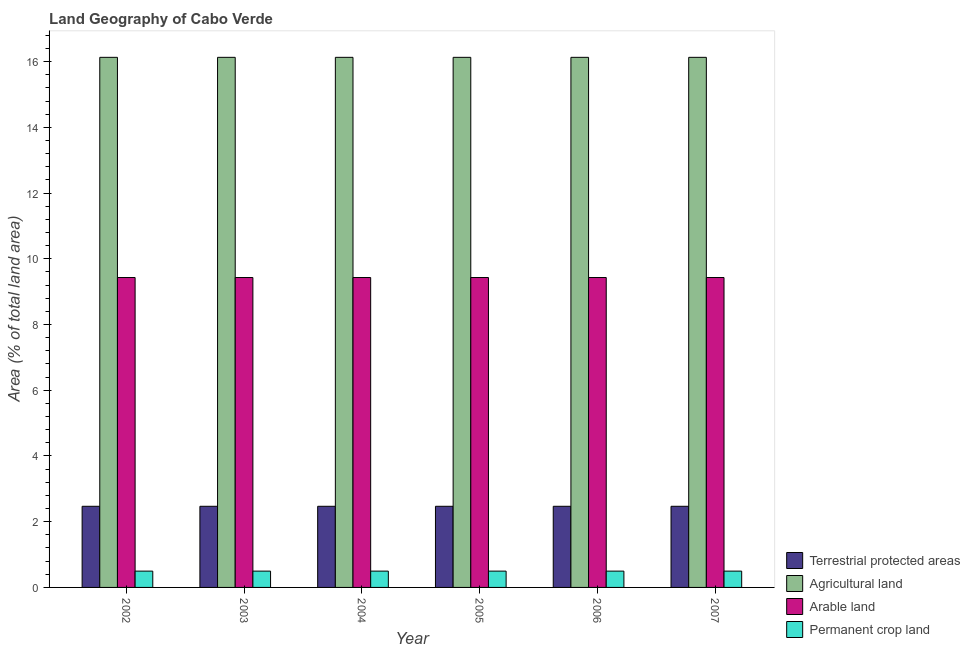How many different coloured bars are there?
Offer a terse response. 4. How many bars are there on the 6th tick from the left?
Offer a terse response. 4. What is the label of the 6th group of bars from the left?
Provide a succinct answer. 2007. In how many cases, is the number of bars for a given year not equal to the number of legend labels?
Offer a very short reply. 0. What is the percentage of area under arable land in 2004?
Provide a succinct answer. 9.43. Across all years, what is the maximum percentage of area under permanent crop land?
Your response must be concise. 0.5. Across all years, what is the minimum percentage of area under arable land?
Give a very brief answer. 9.43. In which year was the percentage of land under terrestrial protection minimum?
Provide a short and direct response. 2002. What is the total percentage of land under terrestrial protection in the graph?
Make the answer very short. 14.81. What is the average percentage of land under terrestrial protection per year?
Ensure brevity in your answer.  2.47. In the year 2004, what is the difference between the percentage of area under permanent crop land and percentage of land under terrestrial protection?
Your response must be concise. 0. In how many years, is the percentage of land under terrestrial protection greater than 8.8 %?
Offer a terse response. 0. What is the ratio of the percentage of area under permanent crop land in 2004 to that in 2005?
Your answer should be compact. 1. Is the percentage of area under agricultural land in 2004 less than that in 2007?
Provide a short and direct response. No. Is the difference between the percentage of area under arable land in 2002 and 2005 greater than the difference between the percentage of land under terrestrial protection in 2002 and 2005?
Provide a succinct answer. No. What is the difference between the highest and the lowest percentage of area under agricultural land?
Your answer should be compact. 0. Is it the case that in every year, the sum of the percentage of area under permanent crop land and percentage of area under arable land is greater than the sum of percentage of land under terrestrial protection and percentage of area under agricultural land?
Give a very brief answer. No. What does the 4th bar from the left in 2002 represents?
Provide a succinct answer. Permanent crop land. What does the 1st bar from the right in 2006 represents?
Your answer should be compact. Permanent crop land. How many bars are there?
Ensure brevity in your answer.  24. Are the values on the major ticks of Y-axis written in scientific E-notation?
Ensure brevity in your answer.  No. Does the graph contain any zero values?
Make the answer very short. No. Does the graph contain grids?
Your response must be concise. No. How many legend labels are there?
Offer a very short reply. 4. How are the legend labels stacked?
Ensure brevity in your answer.  Vertical. What is the title of the graph?
Your answer should be compact. Land Geography of Cabo Verde. Does "Regional development banks" appear as one of the legend labels in the graph?
Keep it short and to the point. No. What is the label or title of the Y-axis?
Keep it short and to the point. Area (% of total land area). What is the Area (% of total land area) of Terrestrial protected areas in 2002?
Offer a terse response. 2.47. What is the Area (% of total land area) in Agricultural land in 2002?
Offer a very short reply. 16.13. What is the Area (% of total land area) in Arable land in 2002?
Make the answer very short. 9.43. What is the Area (% of total land area) in Permanent crop land in 2002?
Offer a very short reply. 0.5. What is the Area (% of total land area) of Terrestrial protected areas in 2003?
Offer a very short reply. 2.47. What is the Area (% of total land area) of Agricultural land in 2003?
Provide a short and direct response. 16.13. What is the Area (% of total land area) in Arable land in 2003?
Provide a succinct answer. 9.43. What is the Area (% of total land area) in Permanent crop land in 2003?
Ensure brevity in your answer.  0.5. What is the Area (% of total land area) in Terrestrial protected areas in 2004?
Your answer should be very brief. 2.47. What is the Area (% of total land area) of Agricultural land in 2004?
Your response must be concise. 16.13. What is the Area (% of total land area) in Arable land in 2004?
Offer a very short reply. 9.43. What is the Area (% of total land area) in Permanent crop land in 2004?
Keep it short and to the point. 0.5. What is the Area (% of total land area) in Terrestrial protected areas in 2005?
Ensure brevity in your answer.  2.47. What is the Area (% of total land area) in Agricultural land in 2005?
Provide a succinct answer. 16.13. What is the Area (% of total land area) of Arable land in 2005?
Offer a terse response. 9.43. What is the Area (% of total land area) in Permanent crop land in 2005?
Offer a terse response. 0.5. What is the Area (% of total land area) of Terrestrial protected areas in 2006?
Provide a short and direct response. 2.47. What is the Area (% of total land area) in Agricultural land in 2006?
Ensure brevity in your answer.  16.13. What is the Area (% of total land area) in Arable land in 2006?
Keep it short and to the point. 9.43. What is the Area (% of total land area) of Permanent crop land in 2006?
Make the answer very short. 0.5. What is the Area (% of total land area) of Terrestrial protected areas in 2007?
Give a very brief answer. 2.47. What is the Area (% of total land area) of Agricultural land in 2007?
Your answer should be compact. 16.13. What is the Area (% of total land area) in Arable land in 2007?
Provide a short and direct response. 9.43. What is the Area (% of total land area) in Permanent crop land in 2007?
Your answer should be compact. 0.5. Across all years, what is the maximum Area (% of total land area) in Terrestrial protected areas?
Offer a very short reply. 2.47. Across all years, what is the maximum Area (% of total land area) in Agricultural land?
Provide a short and direct response. 16.13. Across all years, what is the maximum Area (% of total land area) in Arable land?
Make the answer very short. 9.43. Across all years, what is the maximum Area (% of total land area) in Permanent crop land?
Offer a terse response. 0.5. Across all years, what is the minimum Area (% of total land area) in Terrestrial protected areas?
Offer a terse response. 2.47. Across all years, what is the minimum Area (% of total land area) in Agricultural land?
Give a very brief answer. 16.13. Across all years, what is the minimum Area (% of total land area) in Arable land?
Ensure brevity in your answer.  9.43. Across all years, what is the minimum Area (% of total land area) in Permanent crop land?
Ensure brevity in your answer.  0.5. What is the total Area (% of total land area) in Terrestrial protected areas in the graph?
Offer a terse response. 14.81. What is the total Area (% of total land area) in Agricultural land in the graph?
Keep it short and to the point. 96.77. What is the total Area (% of total land area) of Arable land in the graph?
Give a very brief answer. 56.58. What is the total Area (% of total land area) in Permanent crop land in the graph?
Your answer should be compact. 2.98. What is the difference between the Area (% of total land area) in Arable land in 2002 and that in 2003?
Make the answer very short. 0. What is the difference between the Area (% of total land area) in Permanent crop land in 2002 and that in 2003?
Provide a succinct answer. 0. What is the difference between the Area (% of total land area) in Agricultural land in 2002 and that in 2004?
Your response must be concise. 0. What is the difference between the Area (% of total land area) of Arable land in 2002 and that in 2004?
Offer a terse response. 0. What is the difference between the Area (% of total land area) in Agricultural land in 2002 and that in 2005?
Provide a short and direct response. 0. What is the difference between the Area (% of total land area) in Permanent crop land in 2002 and that in 2005?
Your answer should be compact. 0. What is the difference between the Area (% of total land area) of Agricultural land in 2002 and that in 2007?
Offer a very short reply. 0. What is the difference between the Area (% of total land area) in Terrestrial protected areas in 2003 and that in 2004?
Provide a short and direct response. 0. What is the difference between the Area (% of total land area) of Permanent crop land in 2003 and that in 2004?
Give a very brief answer. 0. What is the difference between the Area (% of total land area) in Terrestrial protected areas in 2003 and that in 2005?
Keep it short and to the point. 0. What is the difference between the Area (% of total land area) of Arable land in 2003 and that in 2005?
Ensure brevity in your answer.  0. What is the difference between the Area (% of total land area) of Arable land in 2003 and that in 2006?
Ensure brevity in your answer.  0. What is the difference between the Area (% of total land area) of Permanent crop land in 2003 and that in 2006?
Your answer should be compact. 0. What is the difference between the Area (% of total land area) in Terrestrial protected areas in 2003 and that in 2007?
Your answer should be very brief. 0. What is the difference between the Area (% of total land area) in Agricultural land in 2003 and that in 2007?
Keep it short and to the point. 0. What is the difference between the Area (% of total land area) of Terrestrial protected areas in 2004 and that in 2005?
Give a very brief answer. 0. What is the difference between the Area (% of total land area) of Arable land in 2004 and that in 2005?
Your response must be concise. 0. What is the difference between the Area (% of total land area) in Permanent crop land in 2004 and that in 2005?
Make the answer very short. 0. What is the difference between the Area (% of total land area) in Arable land in 2004 and that in 2006?
Make the answer very short. 0. What is the difference between the Area (% of total land area) of Permanent crop land in 2004 and that in 2006?
Provide a short and direct response. 0. What is the difference between the Area (% of total land area) of Terrestrial protected areas in 2004 and that in 2007?
Your response must be concise. 0. What is the difference between the Area (% of total land area) of Agricultural land in 2004 and that in 2007?
Offer a terse response. 0. What is the difference between the Area (% of total land area) of Arable land in 2005 and that in 2006?
Offer a terse response. 0. What is the difference between the Area (% of total land area) of Permanent crop land in 2005 and that in 2007?
Your answer should be compact. 0. What is the difference between the Area (% of total land area) of Terrestrial protected areas in 2006 and that in 2007?
Give a very brief answer. 0. What is the difference between the Area (% of total land area) in Terrestrial protected areas in 2002 and the Area (% of total land area) in Agricultural land in 2003?
Your response must be concise. -13.66. What is the difference between the Area (% of total land area) in Terrestrial protected areas in 2002 and the Area (% of total land area) in Arable land in 2003?
Provide a short and direct response. -6.96. What is the difference between the Area (% of total land area) in Terrestrial protected areas in 2002 and the Area (% of total land area) in Permanent crop land in 2003?
Provide a succinct answer. 1.97. What is the difference between the Area (% of total land area) in Agricultural land in 2002 and the Area (% of total land area) in Arable land in 2003?
Give a very brief answer. 6.7. What is the difference between the Area (% of total land area) in Agricultural land in 2002 and the Area (% of total land area) in Permanent crop land in 2003?
Your answer should be compact. 15.63. What is the difference between the Area (% of total land area) in Arable land in 2002 and the Area (% of total land area) in Permanent crop land in 2003?
Provide a short and direct response. 8.93. What is the difference between the Area (% of total land area) of Terrestrial protected areas in 2002 and the Area (% of total land area) of Agricultural land in 2004?
Offer a terse response. -13.66. What is the difference between the Area (% of total land area) in Terrestrial protected areas in 2002 and the Area (% of total land area) in Arable land in 2004?
Ensure brevity in your answer.  -6.96. What is the difference between the Area (% of total land area) in Terrestrial protected areas in 2002 and the Area (% of total land area) in Permanent crop land in 2004?
Give a very brief answer. 1.97. What is the difference between the Area (% of total land area) of Agricultural land in 2002 and the Area (% of total land area) of Arable land in 2004?
Make the answer very short. 6.7. What is the difference between the Area (% of total land area) in Agricultural land in 2002 and the Area (% of total land area) in Permanent crop land in 2004?
Ensure brevity in your answer.  15.63. What is the difference between the Area (% of total land area) of Arable land in 2002 and the Area (% of total land area) of Permanent crop land in 2004?
Keep it short and to the point. 8.93. What is the difference between the Area (% of total land area) of Terrestrial protected areas in 2002 and the Area (% of total land area) of Agricultural land in 2005?
Your response must be concise. -13.66. What is the difference between the Area (% of total land area) of Terrestrial protected areas in 2002 and the Area (% of total land area) of Arable land in 2005?
Provide a succinct answer. -6.96. What is the difference between the Area (% of total land area) of Terrestrial protected areas in 2002 and the Area (% of total land area) of Permanent crop land in 2005?
Your response must be concise. 1.97. What is the difference between the Area (% of total land area) in Agricultural land in 2002 and the Area (% of total land area) in Arable land in 2005?
Your answer should be very brief. 6.7. What is the difference between the Area (% of total land area) of Agricultural land in 2002 and the Area (% of total land area) of Permanent crop land in 2005?
Ensure brevity in your answer.  15.63. What is the difference between the Area (% of total land area) in Arable land in 2002 and the Area (% of total land area) in Permanent crop land in 2005?
Provide a short and direct response. 8.93. What is the difference between the Area (% of total land area) of Terrestrial protected areas in 2002 and the Area (% of total land area) of Agricultural land in 2006?
Your answer should be very brief. -13.66. What is the difference between the Area (% of total land area) of Terrestrial protected areas in 2002 and the Area (% of total land area) of Arable land in 2006?
Give a very brief answer. -6.96. What is the difference between the Area (% of total land area) in Terrestrial protected areas in 2002 and the Area (% of total land area) in Permanent crop land in 2006?
Keep it short and to the point. 1.97. What is the difference between the Area (% of total land area) in Agricultural land in 2002 and the Area (% of total land area) in Arable land in 2006?
Provide a short and direct response. 6.7. What is the difference between the Area (% of total land area) of Agricultural land in 2002 and the Area (% of total land area) of Permanent crop land in 2006?
Ensure brevity in your answer.  15.63. What is the difference between the Area (% of total land area) of Arable land in 2002 and the Area (% of total land area) of Permanent crop land in 2006?
Provide a succinct answer. 8.93. What is the difference between the Area (% of total land area) in Terrestrial protected areas in 2002 and the Area (% of total land area) in Agricultural land in 2007?
Make the answer very short. -13.66. What is the difference between the Area (% of total land area) in Terrestrial protected areas in 2002 and the Area (% of total land area) in Arable land in 2007?
Give a very brief answer. -6.96. What is the difference between the Area (% of total land area) of Terrestrial protected areas in 2002 and the Area (% of total land area) of Permanent crop land in 2007?
Provide a succinct answer. 1.97. What is the difference between the Area (% of total land area) of Agricultural land in 2002 and the Area (% of total land area) of Arable land in 2007?
Make the answer very short. 6.7. What is the difference between the Area (% of total land area) of Agricultural land in 2002 and the Area (% of total land area) of Permanent crop land in 2007?
Provide a short and direct response. 15.63. What is the difference between the Area (% of total land area) of Arable land in 2002 and the Area (% of total land area) of Permanent crop land in 2007?
Offer a very short reply. 8.93. What is the difference between the Area (% of total land area) in Terrestrial protected areas in 2003 and the Area (% of total land area) in Agricultural land in 2004?
Your response must be concise. -13.66. What is the difference between the Area (% of total land area) of Terrestrial protected areas in 2003 and the Area (% of total land area) of Arable land in 2004?
Keep it short and to the point. -6.96. What is the difference between the Area (% of total land area) of Terrestrial protected areas in 2003 and the Area (% of total land area) of Permanent crop land in 2004?
Keep it short and to the point. 1.97. What is the difference between the Area (% of total land area) in Agricultural land in 2003 and the Area (% of total land area) in Arable land in 2004?
Ensure brevity in your answer.  6.7. What is the difference between the Area (% of total land area) of Agricultural land in 2003 and the Area (% of total land area) of Permanent crop land in 2004?
Your answer should be compact. 15.63. What is the difference between the Area (% of total land area) in Arable land in 2003 and the Area (% of total land area) in Permanent crop land in 2004?
Offer a very short reply. 8.93. What is the difference between the Area (% of total land area) of Terrestrial protected areas in 2003 and the Area (% of total land area) of Agricultural land in 2005?
Offer a terse response. -13.66. What is the difference between the Area (% of total land area) in Terrestrial protected areas in 2003 and the Area (% of total land area) in Arable land in 2005?
Give a very brief answer. -6.96. What is the difference between the Area (% of total land area) of Terrestrial protected areas in 2003 and the Area (% of total land area) of Permanent crop land in 2005?
Give a very brief answer. 1.97. What is the difference between the Area (% of total land area) of Agricultural land in 2003 and the Area (% of total land area) of Arable land in 2005?
Offer a terse response. 6.7. What is the difference between the Area (% of total land area) in Agricultural land in 2003 and the Area (% of total land area) in Permanent crop land in 2005?
Provide a succinct answer. 15.63. What is the difference between the Area (% of total land area) in Arable land in 2003 and the Area (% of total land area) in Permanent crop land in 2005?
Provide a succinct answer. 8.93. What is the difference between the Area (% of total land area) in Terrestrial protected areas in 2003 and the Area (% of total land area) in Agricultural land in 2006?
Your response must be concise. -13.66. What is the difference between the Area (% of total land area) of Terrestrial protected areas in 2003 and the Area (% of total land area) of Arable land in 2006?
Your response must be concise. -6.96. What is the difference between the Area (% of total land area) of Terrestrial protected areas in 2003 and the Area (% of total land area) of Permanent crop land in 2006?
Make the answer very short. 1.97. What is the difference between the Area (% of total land area) of Agricultural land in 2003 and the Area (% of total land area) of Arable land in 2006?
Offer a very short reply. 6.7. What is the difference between the Area (% of total land area) of Agricultural land in 2003 and the Area (% of total land area) of Permanent crop land in 2006?
Offer a very short reply. 15.63. What is the difference between the Area (% of total land area) of Arable land in 2003 and the Area (% of total land area) of Permanent crop land in 2006?
Offer a terse response. 8.93. What is the difference between the Area (% of total land area) of Terrestrial protected areas in 2003 and the Area (% of total land area) of Agricultural land in 2007?
Ensure brevity in your answer.  -13.66. What is the difference between the Area (% of total land area) of Terrestrial protected areas in 2003 and the Area (% of total land area) of Arable land in 2007?
Ensure brevity in your answer.  -6.96. What is the difference between the Area (% of total land area) of Terrestrial protected areas in 2003 and the Area (% of total land area) of Permanent crop land in 2007?
Offer a terse response. 1.97. What is the difference between the Area (% of total land area) in Agricultural land in 2003 and the Area (% of total land area) in Arable land in 2007?
Offer a very short reply. 6.7. What is the difference between the Area (% of total land area) of Agricultural land in 2003 and the Area (% of total land area) of Permanent crop land in 2007?
Ensure brevity in your answer.  15.63. What is the difference between the Area (% of total land area) of Arable land in 2003 and the Area (% of total land area) of Permanent crop land in 2007?
Offer a terse response. 8.93. What is the difference between the Area (% of total land area) of Terrestrial protected areas in 2004 and the Area (% of total land area) of Agricultural land in 2005?
Make the answer very short. -13.66. What is the difference between the Area (% of total land area) of Terrestrial protected areas in 2004 and the Area (% of total land area) of Arable land in 2005?
Offer a very short reply. -6.96. What is the difference between the Area (% of total land area) of Terrestrial protected areas in 2004 and the Area (% of total land area) of Permanent crop land in 2005?
Your response must be concise. 1.97. What is the difference between the Area (% of total land area) in Agricultural land in 2004 and the Area (% of total land area) in Arable land in 2005?
Your answer should be very brief. 6.7. What is the difference between the Area (% of total land area) of Agricultural land in 2004 and the Area (% of total land area) of Permanent crop land in 2005?
Offer a terse response. 15.63. What is the difference between the Area (% of total land area) in Arable land in 2004 and the Area (% of total land area) in Permanent crop land in 2005?
Keep it short and to the point. 8.93. What is the difference between the Area (% of total land area) of Terrestrial protected areas in 2004 and the Area (% of total land area) of Agricultural land in 2006?
Provide a succinct answer. -13.66. What is the difference between the Area (% of total land area) in Terrestrial protected areas in 2004 and the Area (% of total land area) in Arable land in 2006?
Offer a terse response. -6.96. What is the difference between the Area (% of total land area) of Terrestrial protected areas in 2004 and the Area (% of total land area) of Permanent crop land in 2006?
Make the answer very short. 1.97. What is the difference between the Area (% of total land area) of Agricultural land in 2004 and the Area (% of total land area) of Arable land in 2006?
Give a very brief answer. 6.7. What is the difference between the Area (% of total land area) in Agricultural land in 2004 and the Area (% of total land area) in Permanent crop land in 2006?
Provide a succinct answer. 15.63. What is the difference between the Area (% of total land area) of Arable land in 2004 and the Area (% of total land area) of Permanent crop land in 2006?
Your response must be concise. 8.93. What is the difference between the Area (% of total land area) in Terrestrial protected areas in 2004 and the Area (% of total land area) in Agricultural land in 2007?
Keep it short and to the point. -13.66. What is the difference between the Area (% of total land area) of Terrestrial protected areas in 2004 and the Area (% of total land area) of Arable land in 2007?
Your answer should be compact. -6.96. What is the difference between the Area (% of total land area) in Terrestrial protected areas in 2004 and the Area (% of total land area) in Permanent crop land in 2007?
Offer a terse response. 1.97. What is the difference between the Area (% of total land area) of Agricultural land in 2004 and the Area (% of total land area) of Arable land in 2007?
Ensure brevity in your answer.  6.7. What is the difference between the Area (% of total land area) of Agricultural land in 2004 and the Area (% of total land area) of Permanent crop land in 2007?
Give a very brief answer. 15.63. What is the difference between the Area (% of total land area) in Arable land in 2004 and the Area (% of total land area) in Permanent crop land in 2007?
Keep it short and to the point. 8.93. What is the difference between the Area (% of total land area) in Terrestrial protected areas in 2005 and the Area (% of total land area) in Agricultural land in 2006?
Give a very brief answer. -13.66. What is the difference between the Area (% of total land area) of Terrestrial protected areas in 2005 and the Area (% of total land area) of Arable land in 2006?
Offer a terse response. -6.96. What is the difference between the Area (% of total land area) of Terrestrial protected areas in 2005 and the Area (% of total land area) of Permanent crop land in 2006?
Provide a succinct answer. 1.97. What is the difference between the Area (% of total land area) of Agricultural land in 2005 and the Area (% of total land area) of Arable land in 2006?
Keep it short and to the point. 6.7. What is the difference between the Area (% of total land area) in Agricultural land in 2005 and the Area (% of total land area) in Permanent crop land in 2006?
Ensure brevity in your answer.  15.63. What is the difference between the Area (% of total land area) in Arable land in 2005 and the Area (% of total land area) in Permanent crop land in 2006?
Your response must be concise. 8.93. What is the difference between the Area (% of total land area) of Terrestrial protected areas in 2005 and the Area (% of total land area) of Agricultural land in 2007?
Your response must be concise. -13.66. What is the difference between the Area (% of total land area) of Terrestrial protected areas in 2005 and the Area (% of total land area) of Arable land in 2007?
Give a very brief answer. -6.96. What is the difference between the Area (% of total land area) in Terrestrial protected areas in 2005 and the Area (% of total land area) in Permanent crop land in 2007?
Ensure brevity in your answer.  1.97. What is the difference between the Area (% of total land area) of Agricultural land in 2005 and the Area (% of total land area) of Arable land in 2007?
Your answer should be compact. 6.7. What is the difference between the Area (% of total land area) in Agricultural land in 2005 and the Area (% of total land area) in Permanent crop land in 2007?
Offer a very short reply. 15.63. What is the difference between the Area (% of total land area) of Arable land in 2005 and the Area (% of total land area) of Permanent crop land in 2007?
Ensure brevity in your answer.  8.93. What is the difference between the Area (% of total land area) of Terrestrial protected areas in 2006 and the Area (% of total land area) of Agricultural land in 2007?
Your response must be concise. -13.66. What is the difference between the Area (% of total land area) in Terrestrial protected areas in 2006 and the Area (% of total land area) in Arable land in 2007?
Offer a very short reply. -6.96. What is the difference between the Area (% of total land area) of Terrestrial protected areas in 2006 and the Area (% of total land area) of Permanent crop land in 2007?
Offer a terse response. 1.97. What is the difference between the Area (% of total land area) of Agricultural land in 2006 and the Area (% of total land area) of Arable land in 2007?
Your answer should be very brief. 6.7. What is the difference between the Area (% of total land area) of Agricultural land in 2006 and the Area (% of total land area) of Permanent crop land in 2007?
Give a very brief answer. 15.63. What is the difference between the Area (% of total land area) in Arable land in 2006 and the Area (% of total land area) in Permanent crop land in 2007?
Your answer should be compact. 8.93. What is the average Area (% of total land area) of Terrestrial protected areas per year?
Give a very brief answer. 2.47. What is the average Area (% of total land area) of Agricultural land per year?
Ensure brevity in your answer.  16.13. What is the average Area (% of total land area) in Arable land per year?
Keep it short and to the point. 9.43. What is the average Area (% of total land area) in Permanent crop land per year?
Provide a succinct answer. 0.5. In the year 2002, what is the difference between the Area (% of total land area) of Terrestrial protected areas and Area (% of total land area) of Agricultural land?
Your answer should be very brief. -13.66. In the year 2002, what is the difference between the Area (% of total land area) in Terrestrial protected areas and Area (% of total land area) in Arable land?
Your answer should be very brief. -6.96. In the year 2002, what is the difference between the Area (% of total land area) in Terrestrial protected areas and Area (% of total land area) in Permanent crop land?
Offer a terse response. 1.97. In the year 2002, what is the difference between the Area (% of total land area) of Agricultural land and Area (% of total land area) of Arable land?
Your answer should be compact. 6.7. In the year 2002, what is the difference between the Area (% of total land area) in Agricultural land and Area (% of total land area) in Permanent crop land?
Your response must be concise. 15.63. In the year 2002, what is the difference between the Area (% of total land area) of Arable land and Area (% of total land area) of Permanent crop land?
Give a very brief answer. 8.93. In the year 2003, what is the difference between the Area (% of total land area) of Terrestrial protected areas and Area (% of total land area) of Agricultural land?
Provide a succinct answer. -13.66. In the year 2003, what is the difference between the Area (% of total land area) in Terrestrial protected areas and Area (% of total land area) in Arable land?
Provide a succinct answer. -6.96. In the year 2003, what is the difference between the Area (% of total land area) of Terrestrial protected areas and Area (% of total land area) of Permanent crop land?
Your answer should be compact. 1.97. In the year 2003, what is the difference between the Area (% of total land area) in Agricultural land and Area (% of total land area) in Arable land?
Your answer should be very brief. 6.7. In the year 2003, what is the difference between the Area (% of total land area) of Agricultural land and Area (% of total land area) of Permanent crop land?
Provide a succinct answer. 15.63. In the year 2003, what is the difference between the Area (% of total land area) of Arable land and Area (% of total land area) of Permanent crop land?
Ensure brevity in your answer.  8.93. In the year 2004, what is the difference between the Area (% of total land area) in Terrestrial protected areas and Area (% of total land area) in Agricultural land?
Your response must be concise. -13.66. In the year 2004, what is the difference between the Area (% of total land area) in Terrestrial protected areas and Area (% of total land area) in Arable land?
Provide a short and direct response. -6.96. In the year 2004, what is the difference between the Area (% of total land area) in Terrestrial protected areas and Area (% of total land area) in Permanent crop land?
Keep it short and to the point. 1.97. In the year 2004, what is the difference between the Area (% of total land area) of Agricultural land and Area (% of total land area) of Arable land?
Offer a terse response. 6.7. In the year 2004, what is the difference between the Area (% of total land area) in Agricultural land and Area (% of total land area) in Permanent crop land?
Ensure brevity in your answer.  15.63. In the year 2004, what is the difference between the Area (% of total land area) of Arable land and Area (% of total land area) of Permanent crop land?
Offer a terse response. 8.93. In the year 2005, what is the difference between the Area (% of total land area) in Terrestrial protected areas and Area (% of total land area) in Agricultural land?
Keep it short and to the point. -13.66. In the year 2005, what is the difference between the Area (% of total land area) in Terrestrial protected areas and Area (% of total land area) in Arable land?
Your answer should be compact. -6.96. In the year 2005, what is the difference between the Area (% of total land area) of Terrestrial protected areas and Area (% of total land area) of Permanent crop land?
Make the answer very short. 1.97. In the year 2005, what is the difference between the Area (% of total land area) of Agricultural land and Area (% of total land area) of Arable land?
Your answer should be compact. 6.7. In the year 2005, what is the difference between the Area (% of total land area) in Agricultural land and Area (% of total land area) in Permanent crop land?
Your answer should be compact. 15.63. In the year 2005, what is the difference between the Area (% of total land area) of Arable land and Area (% of total land area) of Permanent crop land?
Offer a very short reply. 8.93. In the year 2006, what is the difference between the Area (% of total land area) of Terrestrial protected areas and Area (% of total land area) of Agricultural land?
Make the answer very short. -13.66. In the year 2006, what is the difference between the Area (% of total land area) in Terrestrial protected areas and Area (% of total land area) in Arable land?
Ensure brevity in your answer.  -6.96. In the year 2006, what is the difference between the Area (% of total land area) of Terrestrial protected areas and Area (% of total land area) of Permanent crop land?
Offer a terse response. 1.97. In the year 2006, what is the difference between the Area (% of total land area) of Agricultural land and Area (% of total land area) of Arable land?
Give a very brief answer. 6.7. In the year 2006, what is the difference between the Area (% of total land area) of Agricultural land and Area (% of total land area) of Permanent crop land?
Offer a terse response. 15.63. In the year 2006, what is the difference between the Area (% of total land area) in Arable land and Area (% of total land area) in Permanent crop land?
Your answer should be very brief. 8.93. In the year 2007, what is the difference between the Area (% of total land area) in Terrestrial protected areas and Area (% of total land area) in Agricultural land?
Your answer should be compact. -13.66. In the year 2007, what is the difference between the Area (% of total land area) in Terrestrial protected areas and Area (% of total land area) in Arable land?
Provide a succinct answer. -6.96. In the year 2007, what is the difference between the Area (% of total land area) of Terrestrial protected areas and Area (% of total land area) of Permanent crop land?
Offer a very short reply. 1.97. In the year 2007, what is the difference between the Area (% of total land area) in Agricultural land and Area (% of total land area) in Arable land?
Provide a succinct answer. 6.7. In the year 2007, what is the difference between the Area (% of total land area) of Agricultural land and Area (% of total land area) of Permanent crop land?
Give a very brief answer. 15.63. In the year 2007, what is the difference between the Area (% of total land area) in Arable land and Area (% of total land area) in Permanent crop land?
Provide a succinct answer. 8.93. What is the ratio of the Area (% of total land area) in Terrestrial protected areas in 2002 to that in 2003?
Keep it short and to the point. 1. What is the ratio of the Area (% of total land area) in Agricultural land in 2002 to that in 2003?
Provide a succinct answer. 1. What is the ratio of the Area (% of total land area) in Arable land in 2002 to that in 2003?
Ensure brevity in your answer.  1. What is the ratio of the Area (% of total land area) of Permanent crop land in 2002 to that in 2003?
Your response must be concise. 1. What is the ratio of the Area (% of total land area) of Terrestrial protected areas in 2002 to that in 2004?
Make the answer very short. 1. What is the ratio of the Area (% of total land area) in Agricultural land in 2002 to that in 2004?
Keep it short and to the point. 1. What is the ratio of the Area (% of total land area) of Terrestrial protected areas in 2002 to that in 2005?
Your answer should be compact. 1. What is the ratio of the Area (% of total land area) in Agricultural land in 2002 to that in 2005?
Offer a terse response. 1. What is the ratio of the Area (% of total land area) in Permanent crop land in 2002 to that in 2005?
Offer a terse response. 1. What is the ratio of the Area (% of total land area) of Terrestrial protected areas in 2002 to that in 2006?
Your answer should be very brief. 1. What is the ratio of the Area (% of total land area) in Arable land in 2002 to that in 2006?
Offer a very short reply. 1. What is the ratio of the Area (% of total land area) in Terrestrial protected areas in 2002 to that in 2007?
Provide a succinct answer. 1. What is the ratio of the Area (% of total land area) of Agricultural land in 2002 to that in 2007?
Offer a terse response. 1. What is the ratio of the Area (% of total land area) in Permanent crop land in 2002 to that in 2007?
Provide a succinct answer. 1. What is the ratio of the Area (% of total land area) in Terrestrial protected areas in 2003 to that in 2004?
Offer a terse response. 1. What is the ratio of the Area (% of total land area) of Agricultural land in 2003 to that in 2004?
Provide a succinct answer. 1. What is the ratio of the Area (% of total land area) of Terrestrial protected areas in 2003 to that in 2005?
Provide a short and direct response. 1. What is the ratio of the Area (% of total land area) in Arable land in 2003 to that in 2005?
Provide a short and direct response. 1. What is the ratio of the Area (% of total land area) in Permanent crop land in 2003 to that in 2005?
Keep it short and to the point. 1. What is the ratio of the Area (% of total land area) of Agricultural land in 2003 to that in 2006?
Ensure brevity in your answer.  1. What is the ratio of the Area (% of total land area) in Arable land in 2003 to that in 2006?
Ensure brevity in your answer.  1. What is the ratio of the Area (% of total land area) in Terrestrial protected areas in 2003 to that in 2007?
Your response must be concise. 1. What is the ratio of the Area (% of total land area) in Arable land in 2003 to that in 2007?
Your answer should be compact. 1. What is the ratio of the Area (% of total land area) in Permanent crop land in 2003 to that in 2007?
Provide a succinct answer. 1. What is the ratio of the Area (% of total land area) of Agricultural land in 2004 to that in 2005?
Your response must be concise. 1. What is the ratio of the Area (% of total land area) in Permanent crop land in 2004 to that in 2006?
Provide a succinct answer. 1. What is the ratio of the Area (% of total land area) of Agricultural land in 2004 to that in 2007?
Provide a short and direct response. 1. What is the ratio of the Area (% of total land area) of Permanent crop land in 2004 to that in 2007?
Offer a terse response. 1. What is the ratio of the Area (% of total land area) in Arable land in 2005 to that in 2006?
Make the answer very short. 1. What is the ratio of the Area (% of total land area) of Terrestrial protected areas in 2005 to that in 2007?
Provide a succinct answer. 1. What is the ratio of the Area (% of total land area) of Agricultural land in 2005 to that in 2007?
Ensure brevity in your answer.  1. What is the ratio of the Area (% of total land area) in Arable land in 2005 to that in 2007?
Keep it short and to the point. 1. What is the ratio of the Area (% of total land area) in Permanent crop land in 2005 to that in 2007?
Offer a terse response. 1. What is the ratio of the Area (% of total land area) in Terrestrial protected areas in 2006 to that in 2007?
Your answer should be very brief. 1. What is the ratio of the Area (% of total land area) in Agricultural land in 2006 to that in 2007?
Provide a short and direct response. 1. What is the ratio of the Area (% of total land area) of Arable land in 2006 to that in 2007?
Make the answer very short. 1. What is the difference between the highest and the second highest Area (% of total land area) of Terrestrial protected areas?
Give a very brief answer. 0. What is the difference between the highest and the second highest Area (% of total land area) of Agricultural land?
Provide a short and direct response. 0. What is the difference between the highest and the lowest Area (% of total land area) in Permanent crop land?
Keep it short and to the point. 0. 